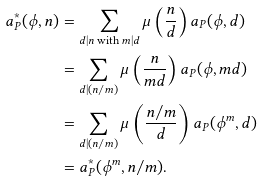Convert formula to latex. <formula><loc_0><loc_0><loc_500><loc_500>a _ { P } ^ { \ast } ( \phi , n ) & = \sum _ { d | n \text { with } m | d } \mu \left ( \frac { n } { d } \right ) a _ { P } ( \phi , d ) \\ & = \sum _ { d | ( n / m ) } \mu \left ( \frac { n } { m d } \right ) a _ { P } ( \phi , m d ) \\ & = \sum _ { d | ( n / m ) } \mu \left ( \frac { n / m } { d } \right ) a _ { P } ( \phi ^ { m } , d ) \\ & = a _ { P } ^ { \ast } ( \phi ^ { m } , n / m ) .</formula> 